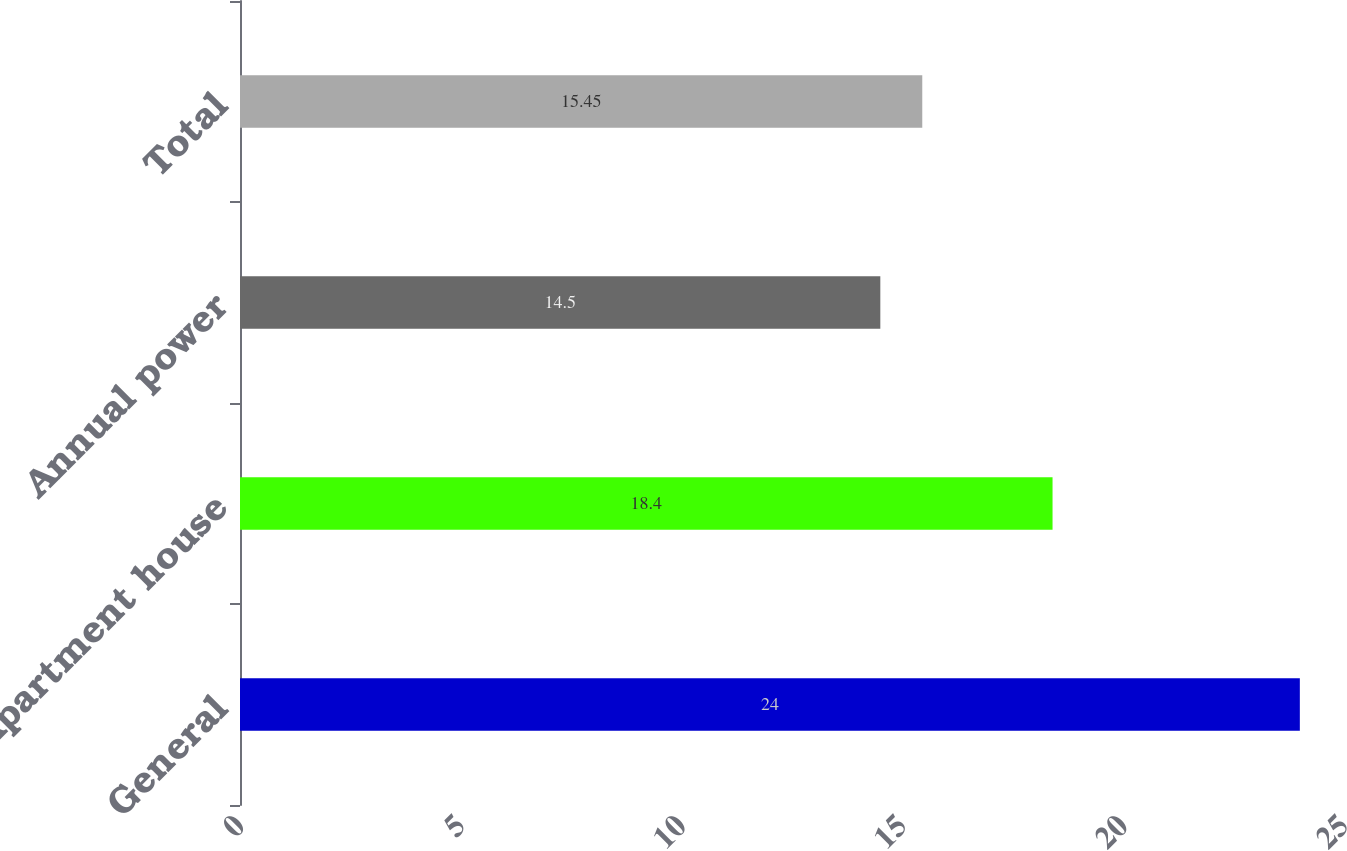<chart> <loc_0><loc_0><loc_500><loc_500><bar_chart><fcel>General<fcel>Apartment house<fcel>Annual power<fcel>Total<nl><fcel>24<fcel>18.4<fcel>14.5<fcel>15.45<nl></chart> 